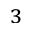<formula> <loc_0><loc_0><loc_500><loc_500>_ { 3 }</formula> 